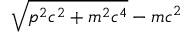Convert formula to latex. <formula><loc_0><loc_0><loc_500><loc_500>\sqrt { p ^ { 2 } c ^ { 2 } + m ^ { 2 } c ^ { 4 } } - m c ^ { 2 }</formula> 